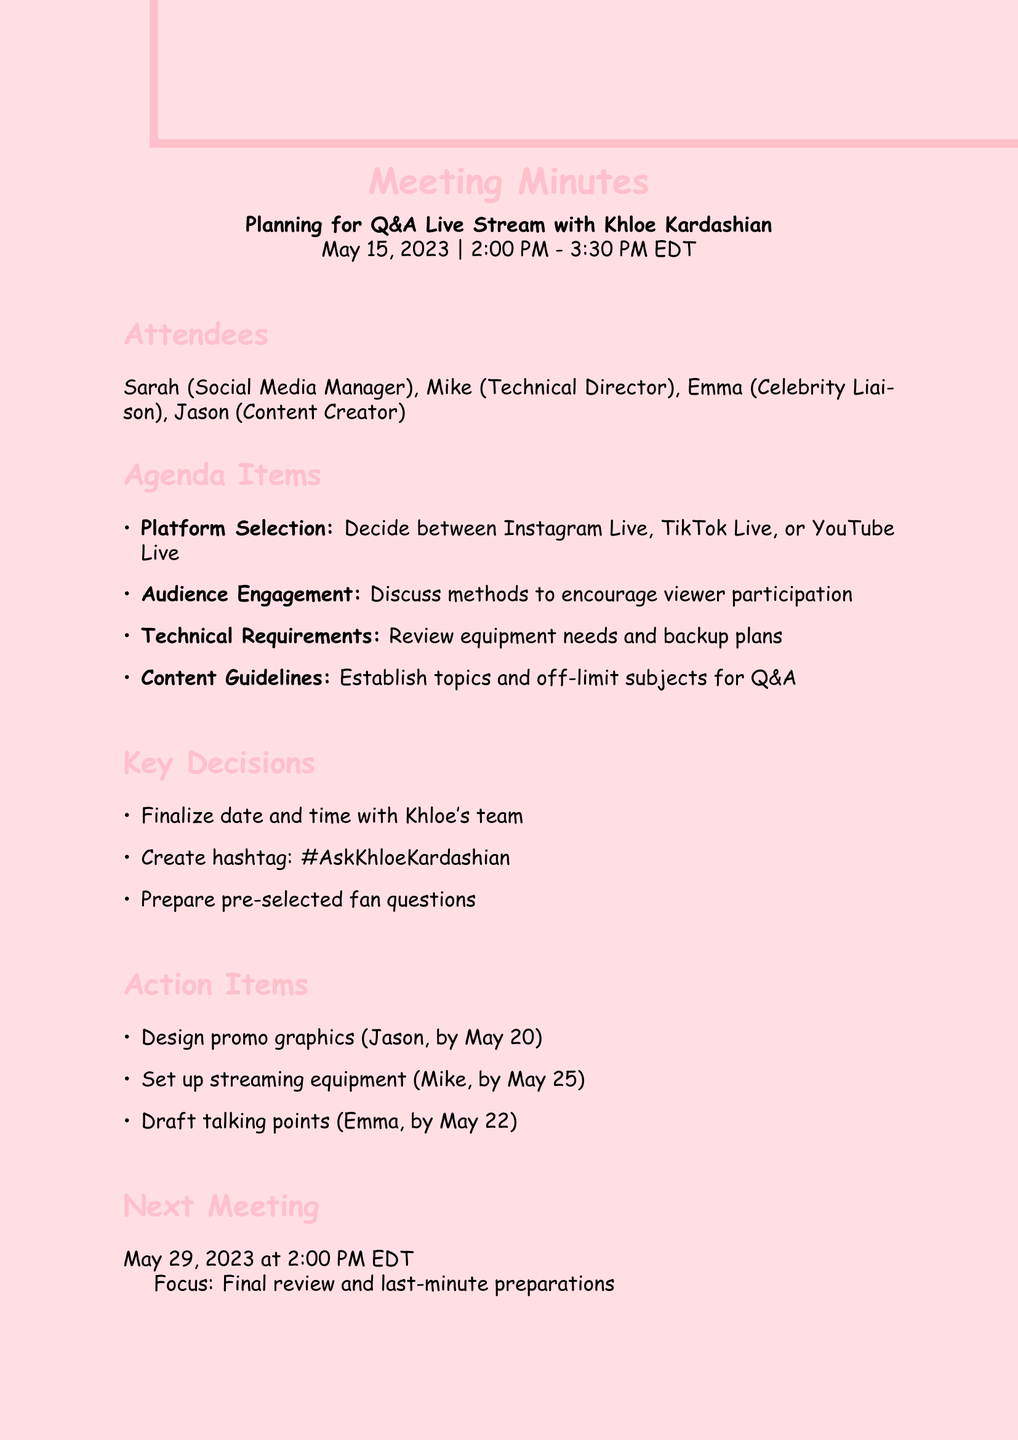What is the date of the meeting? The date of the meeting is specified in the document as May 15, 2023.
Answer: May 15, 2023 Who is the Technical Director? The role of Technical Director is assigned to Mike in the meeting minutes.
Answer: Mike What is the key hashtag created for the event? A key decision recorded in the meeting is the creation of a hashtag for the event, specifically #AskKhloeKardashian.
Answer: #AskKhloeKardashian What is the focus of the next meeting? The focus for the next meeting is indicated as a final review of event details and last-minute preparations.
Answer: Final review of event details and last-minute preparations Who is responsible for setting up the streaming equipment and when is it due? The document assigns the task of setting up streaming equipment to Mike, with a deadline provided in the action items.
Answer: Mike, by May 25, 2023 What are the three platforms considered for the live stream? The meeting agenda details the platform selection, listing three options for the live stream session.
Answer: Instagram Live, TikTok Live, or YouTube Live What is one method discussed for audience engagement? The agenda includes a discussion on methods to encourage viewer participation, which falls under audience engagement strategies.
Answer: Encourage viewer participation How long is the meeting scheduled to last? The duration of the meeting is specified from start to end time in the details section.
Answer: 1.5 hours 